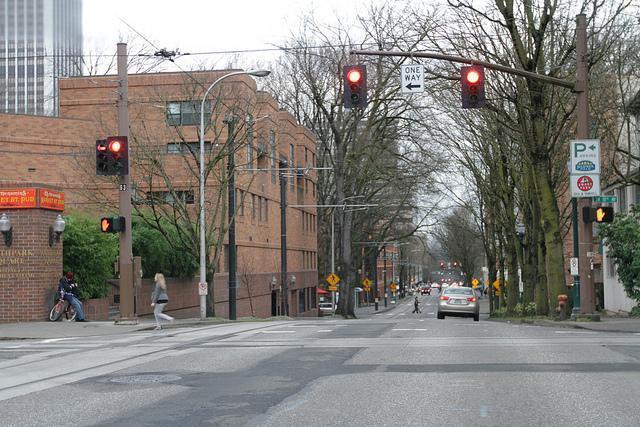Where do you think this is located?
Choose the correct response, then elucidate: 'Answer: answer
Rationale: rationale.'
Options: Countryside, farm, school, city. Answer: city.
Rationale: It looks like the business area of a city. 